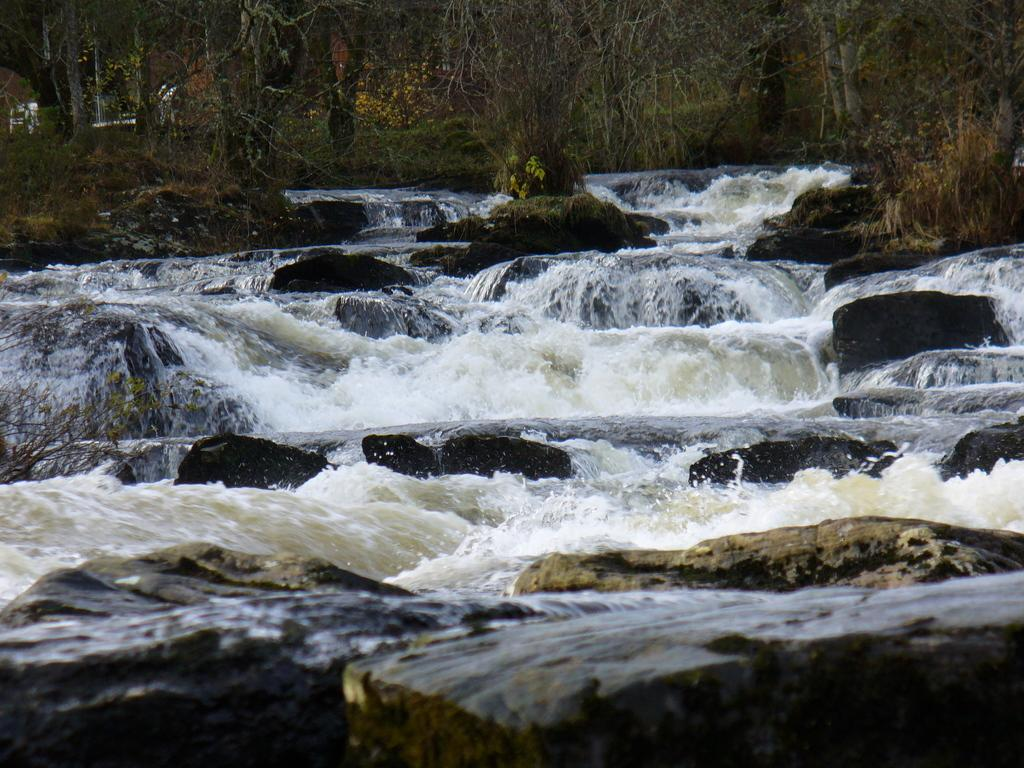What is the primary element in the image? There is flowing water in the image. What else can be seen in the image besides the water? There are rocks in the image. What is visible in the background of the image? There are trees in the background of the image. What type of scent can be detected from the rocks in the image? There is no indication of a scent in the image, as it is a visual representation. 